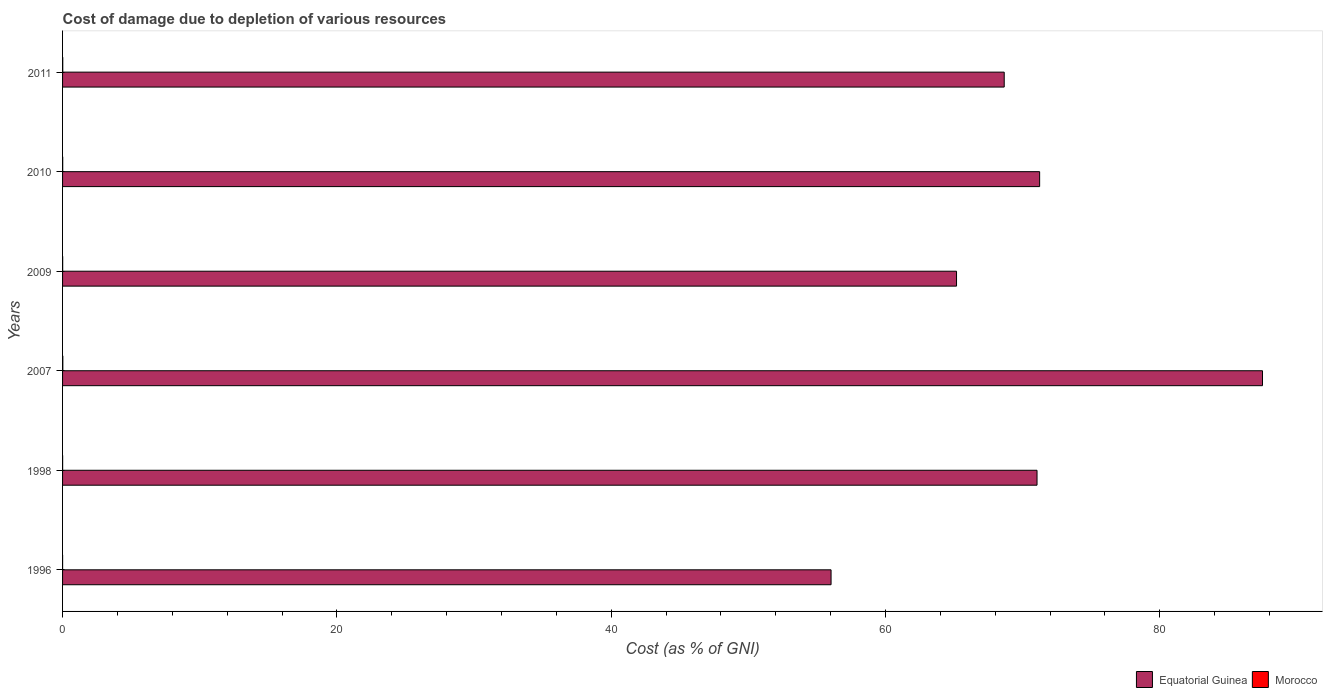Are the number of bars on each tick of the Y-axis equal?
Provide a succinct answer. Yes. How many bars are there on the 5th tick from the top?
Provide a short and direct response. 2. In how many cases, is the number of bars for a given year not equal to the number of legend labels?
Your response must be concise. 0. What is the cost of damage caused due to the depletion of various resources in Morocco in 2009?
Keep it short and to the point. 0.01. Across all years, what is the maximum cost of damage caused due to the depletion of various resources in Equatorial Guinea?
Your answer should be compact. 87.49. Across all years, what is the minimum cost of damage caused due to the depletion of various resources in Morocco?
Keep it short and to the point. 0. In which year was the cost of damage caused due to the depletion of various resources in Equatorial Guinea maximum?
Your answer should be compact. 2007. In which year was the cost of damage caused due to the depletion of various resources in Equatorial Guinea minimum?
Provide a short and direct response. 1996. What is the total cost of damage caused due to the depletion of various resources in Equatorial Guinea in the graph?
Offer a very short reply. 419.63. What is the difference between the cost of damage caused due to the depletion of various resources in Equatorial Guinea in 1996 and that in 2011?
Offer a very short reply. -12.62. What is the difference between the cost of damage caused due to the depletion of various resources in Morocco in 2010 and the cost of damage caused due to the depletion of various resources in Equatorial Guinea in 1996?
Give a very brief answer. -56.02. What is the average cost of damage caused due to the depletion of various resources in Equatorial Guinea per year?
Provide a short and direct response. 69.94. In the year 2007, what is the difference between the cost of damage caused due to the depletion of various resources in Morocco and cost of damage caused due to the depletion of various resources in Equatorial Guinea?
Offer a very short reply. -87.47. What is the ratio of the cost of damage caused due to the depletion of various resources in Morocco in 2007 to that in 2009?
Make the answer very short. 2.58. Is the cost of damage caused due to the depletion of various resources in Morocco in 2009 less than that in 2010?
Offer a terse response. Yes. What is the difference between the highest and the second highest cost of damage caused due to the depletion of various resources in Morocco?
Make the answer very short. 0.01. What is the difference between the highest and the lowest cost of damage caused due to the depletion of various resources in Morocco?
Provide a short and direct response. 0.02. What does the 2nd bar from the top in 1996 represents?
Ensure brevity in your answer.  Equatorial Guinea. What does the 2nd bar from the bottom in 2011 represents?
Provide a succinct answer. Morocco. Are all the bars in the graph horizontal?
Ensure brevity in your answer.  Yes. Are the values on the major ticks of X-axis written in scientific E-notation?
Your response must be concise. No. Does the graph contain grids?
Your answer should be compact. No. Where does the legend appear in the graph?
Give a very brief answer. Bottom right. What is the title of the graph?
Give a very brief answer. Cost of damage due to depletion of various resources. Does "Netherlands" appear as one of the legend labels in the graph?
Ensure brevity in your answer.  No. What is the label or title of the X-axis?
Keep it short and to the point. Cost (as % of GNI). What is the label or title of the Y-axis?
Provide a succinct answer. Years. What is the Cost (as % of GNI) of Equatorial Guinea in 1996?
Your answer should be compact. 56.03. What is the Cost (as % of GNI) in Morocco in 1996?
Provide a succinct answer. 0. What is the Cost (as % of GNI) in Equatorial Guinea in 1998?
Offer a very short reply. 71.05. What is the Cost (as % of GNI) in Morocco in 1998?
Make the answer very short. 0. What is the Cost (as % of GNI) of Equatorial Guinea in 2007?
Your answer should be compact. 87.49. What is the Cost (as % of GNI) of Morocco in 2007?
Your response must be concise. 0.02. What is the Cost (as % of GNI) of Equatorial Guinea in 2009?
Ensure brevity in your answer.  65.18. What is the Cost (as % of GNI) of Morocco in 2009?
Provide a short and direct response. 0.01. What is the Cost (as % of GNI) of Equatorial Guinea in 2010?
Offer a terse response. 71.24. What is the Cost (as % of GNI) in Morocco in 2010?
Make the answer very short. 0.01. What is the Cost (as % of GNI) in Equatorial Guinea in 2011?
Make the answer very short. 68.65. What is the Cost (as % of GNI) in Morocco in 2011?
Give a very brief answer. 0.01. Across all years, what is the maximum Cost (as % of GNI) of Equatorial Guinea?
Ensure brevity in your answer.  87.49. Across all years, what is the maximum Cost (as % of GNI) of Morocco?
Make the answer very short. 0.02. Across all years, what is the minimum Cost (as % of GNI) of Equatorial Guinea?
Offer a terse response. 56.03. Across all years, what is the minimum Cost (as % of GNI) in Morocco?
Your response must be concise. 0. What is the total Cost (as % of GNI) in Equatorial Guinea in the graph?
Keep it short and to the point. 419.63. What is the total Cost (as % of GNI) of Morocco in the graph?
Your response must be concise. 0.06. What is the difference between the Cost (as % of GNI) of Equatorial Guinea in 1996 and that in 1998?
Your answer should be very brief. -15.02. What is the difference between the Cost (as % of GNI) of Morocco in 1996 and that in 1998?
Offer a terse response. -0. What is the difference between the Cost (as % of GNI) of Equatorial Guinea in 1996 and that in 2007?
Your response must be concise. -31.45. What is the difference between the Cost (as % of GNI) of Morocco in 1996 and that in 2007?
Give a very brief answer. -0.02. What is the difference between the Cost (as % of GNI) of Equatorial Guinea in 1996 and that in 2009?
Keep it short and to the point. -9.15. What is the difference between the Cost (as % of GNI) in Morocco in 1996 and that in 2009?
Your answer should be compact. -0. What is the difference between the Cost (as % of GNI) of Equatorial Guinea in 1996 and that in 2010?
Provide a short and direct response. -15.21. What is the difference between the Cost (as % of GNI) of Morocco in 1996 and that in 2010?
Give a very brief answer. -0.01. What is the difference between the Cost (as % of GNI) of Equatorial Guinea in 1996 and that in 2011?
Keep it short and to the point. -12.62. What is the difference between the Cost (as % of GNI) of Morocco in 1996 and that in 2011?
Your answer should be compact. -0.01. What is the difference between the Cost (as % of GNI) in Equatorial Guinea in 1998 and that in 2007?
Your answer should be very brief. -16.44. What is the difference between the Cost (as % of GNI) of Morocco in 1998 and that in 2007?
Provide a succinct answer. -0.01. What is the difference between the Cost (as % of GNI) of Equatorial Guinea in 1998 and that in 2009?
Your answer should be compact. 5.87. What is the difference between the Cost (as % of GNI) of Morocco in 1998 and that in 2009?
Provide a short and direct response. -0. What is the difference between the Cost (as % of GNI) in Equatorial Guinea in 1998 and that in 2010?
Your response must be concise. -0.19. What is the difference between the Cost (as % of GNI) of Morocco in 1998 and that in 2010?
Your answer should be very brief. -0.01. What is the difference between the Cost (as % of GNI) in Equatorial Guinea in 1998 and that in 2011?
Your response must be concise. 2.39. What is the difference between the Cost (as % of GNI) in Morocco in 1998 and that in 2011?
Your response must be concise. -0.01. What is the difference between the Cost (as % of GNI) of Equatorial Guinea in 2007 and that in 2009?
Offer a terse response. 22.31. What is the difference between the Cost (as % of GNI) in Morocco in 2007 and that in 2009?
Your answer should be compact. 0.01. What is the difference between the Cost (as % of GNI) of Equatorial Guinea in 2007 and that in 2010?
Provide a succinct answer. 16.25. What is the difference between the Cost (as % of GNI) of Morocco in 2007 and that in 2010?
Provide a short and direct response. 0.01. What is the difference between the Cost (as % of GNI) of Equatorial Guinea in 2007 and that in 2011?
Give a very brief answer. 18.83. What is the difference between the Cost (as % of GNI) of Morocco in 2007 and that in 2011?
Offer a terse response. 0.01. What is the difference between the Cost (as % of GNI) in Equatorial Guinea in 2009 and that in 2010?
Provide a succinct answer. -6.06. What is the difference between the Cost (as % of GNI) of Morocco in 2009 and that in 2010?
Offer a very short reply. -0. What is the difference between the Cost (as % of GNI) in Equatorial Guinea in 2009 and that in 2011?
Your answer should be very brief. -3.48. What is the difference between the Cost (as % of GNI) in Morocco in 2009 and that in 2011?
Ensure brevity in your answer.  -0.01. What is the difference between the Cost (as % of GNI) in Equatorial Guinea in 2010 and that in 2011?
Offer a terse response. 2.58. What is the difference between the Cost (as % of GNI) in Morocco in 2010 and that in 2011?
Your response must be concise. -0. What is the difference between the Cost (as % of GNI) of Equatorial Guinea in 1996 and the Cost (as % of GNI) of Morocco in 1998?
Provide a short and direct response. 56.03. What is the difference between the Cost (as % of GNI) of Equatorial Guinea in 1996 and the Cost (as % of GNI) of Morocco in 2007?
Your answer should be very brief. 56.01. What is the difference between the Cost (as % of GNI) in Equatorial Guinea in 1996 and the Cost (as % of GNI) in Morocco in 2009?
Your response must be concise. 56.02. What is the difference between the Cost (as % of GNI) in Equatorial Guinea in 1996 and the Cost (as % of GNI) in Morocco in 2010?
Provide a succinct answer. 56.02. What is the difference between the Cost (as % of GNI) of Equatorial Guinea in 1996 and the Cost (as % of GNI) of Morocco in 2011?
Your response must be concise. 56.02. What is the difference between the Cost (as % of GNI) of Equatorial Guinea in 1998 and the Cost (as % of GNI) of Morocco in 2007?
Your answer should be very brief. 71.03. What is the difference between the Cost (as % of GNI) of Equatorial Guinea in 1998 and the Cost (as % of GNI) of Morocco in 2009?
Your answer should be very brief. 71.04. What is the difference between the Cost (as % of GNI) of Equatorial Guinea in 1998 and the Cost (as % of GNI) of Morocco in 2010?
Your answer should be very brief. 71.04. What is the difference between the Cost (as % of GNI) of Equatorial Guinea in 1998 and the Cost (as % of GNI) of Morocco in 2011?
Provide a short and direct response. 71.03. What is the difference between the Cost (as % of GNI) of Equatorial Guinea in 2007 and the Cost (as % of GNI) of Morocco in 2009?
Give a very brief answer. 87.48. What is the difference between the Cost (as % of GNI) of Equatorial Guinea in 2007 and the Cost (as % of GNI) of Morocco in 2010?
Give a very brief answer. 87.48. What is the difference between the Cost (as % of GNI) of Equatorial Guinea in 2007 and the Cost (as % of GNI) of Morocco in 2011?
Ensure brevity in your answer.  87.47. What is the difference between the Cost (as % of GNI) in Equatorial Guinea in 2009 and the Cost (as % of GNI) in Morocco in 2010?
Ensure brevity in your answer.  65.17. What is the difference between the Cost (as % of GNI) of Equatorial Guinea in 2009 and the Cost (as % of GNI) of Morocco in 2011?
Provide a succinct answer. 65.16. What is the difference between the Cost (as % of GNI) in Equatorial Guinea in 2010 and the Cost (as % of GNI) in Morocco in 2011?
Your response must be concise. 71.22. What is the average Cost (as % of GNI) of Equatorial Guinea per year?
Give a very brief answer. 69.94. What is the average Cost (as % of GNI) in Morocco per year?
Provide a short and direct response. 0.01. In the year 1996, what is the difference between the Cost (as % of GNI) in Equatorial Guinea and Cost (as % of GNI) in Morocco?
Ensure brevity in your answer.  56.03. In the year 1998, what is the difference between the Cost (as % of GNI) of Equatorial Guinea and Cost (as % of GNI) of Morocco?
Provide a succinct answer. 71.04. In the year 2007, what is the difference between the Cost (as % of GNI) of Equatorial Guinea and Cost (as % of GNI) of Morocco?
Ensure brevity in your answer.  87.47. In the year 2009, what is the difference between the Cost (as % of GNI) in Equatorial Guinea and Cost (as % of GNI) in Morocco?
Give a very brief answer. 65.17. In the year 2010, what is the difference between the Cost (as % of GNI) in Equatorial Guinea and Cost (as % of GNI) in Morocco?
Your answer should be compact. 71.23. In the year 2011, what is the difference between the Cost (as % of GNI) of Equatorial Guinea and Cost (as % of GNI) of Morocco?
Keep it short and to the point. 68.64. What is the ratio of the Cost (as % of GNI) in Equatorial Guinea in 1996 to that in 1998?
Your answer should be compact. 0.79. What is the ratio of the Cost (as % of GNI) in Morocco in 1996 to that in 1998?
Provide a succinct answer. 0.6. What is the ratio of the Cost (as % of GNI) in Equatorial Guinea in 1996 to that in 2007?
Your answer should be compact. 0.64. What is the ratio of the Cost (as % of GNI) of Morocco in 1996 to that in 2007?
Your answer should be very brief. 0.13. What is the ratio of the Cost (as % of GNI) in Equatorial Guinea in 1996 to that in 2009?
Provide a short and direct response. 0.86. What is the ratio of the Cost (as % of GNI) in Morocco in 1996 to that in 2009?
Offer a very short reply. 0.33. What is the ratio of the Cost (as % of GNI) in Equatorial Guinea in 1996 to that in 2010?
Give a very brief answer. 0.79. What is the ratio of the Cost (as % of GNI) in Morocco in 1996 to that in 2010?
Your answer should be compact. 0.23. What is the ratio of the Cost (as % of GNI) of Equatorial Guinea in 1996 to that in 2011?
Offer a terse response. 0.82. What is the ratio of the Cost (as % of GNI) of Morocco in 1996 to that in 2011?
Your response must be concise. 0.19. What is the ratio of the Cost (as % of GNI) of Equatorial Guinea in 1998 to that in 2007?
Make the answer very short. 0.81. What is the ratio of the Cost (as % of GNI) of Morocco in 1998 to that in 2007?
Keep it short and to the point. 0.22. What is the ratio of the Cost (as % of GNI) in Equatorial Guinea in 1998 to that in 2009?
Offer a very short reply. 1.09. What is the ratio of the Cost (as % of GNI) in Morocco in 1998 to that in 2009?
Offer a very short reply. 0.56. What is the ratio of the Cost (as % of GNI) in Morocco in 1998 to that in 2010?
Your answer should be compact. 0.39. What is the ratio of the Cost (as % of GNI) in Equatorial Guinea in 1998 to that in 2011?
Offer a terse response. 1.03. What is the ratio of the Cost (as % of GNI) in Morocco in 1998 to that in 2011?
Offer a very short reply. 0.32. What is the ratio of the Cost (as % of GNI) in Equatorial Guinea in 2007 to that in 2009?
Provide a succinct answer. 1.34. What is the ratio of the Cost (as % of GNI) in Morocco in 2007 to that in 2009?
Your answer should be very brief. 2.58. What is the ratio of the Cost (as % of GNI) of Equatorial Guinea in 2007 to that in 2010?
Offer a terse response. 1.23. What is the ratio of the Cost (as % of GNI) in Morocco in 2007 to that in 2010?
Make the answer very short. 1.81. What is the ratio of the Cost (as % of GNI) in Equatorial Guinea in 2007 to that in 2011?
Your answer should be compact. 1.27. What is the ratio of the Cost (as % of GNI) in Morocco in 2007 to that in 2011?
Give a very brief answer. 1.47. What is the ratio of the Cost (as % of GNI) in Equatorial Guinea in 2009 to that in 2010?
Provide a succinct answer. 0.91. What is the ratio of the Cost (as % of GNI) of Morocco in 2009 to that in 2010?
Keep it short and to the point. 0.7. What is the ratio of the Cost (as % of GNI) of Equatorial Guinea in 2009 to that in 2011?
Offer a very short reply. 0.95. What is the ratio of the Cost (as % of GNI) in Morocco in 2009 to that in 2011?
Keep it short and to the point. 0.57. What is the ratio of the Cost (as % of GNI) of Equatorial Guinea in 2010 to that in 2011?
Provide a succinct answer. 1.04. What is the ratio of the Cost (as % of GNI) in Morocco in 2010 to that in 2011?
Your answer should be very brief. 0.81. What is the difference between the highest and the second highest Cost (as % of GNI) of Equatorial Guinea?
Your answer should be compact. 16.25. What is the difference between the highest and the second highest Cost (as % of GNI) of Morocco?
Provide a succinct answer. 0.01. What is the difference between the highest and the lowest Cost (as % of GNI) of Equatorial Guinea?
Offer a terse response. 31.45. What is the difference between the highest and the lowest Cost (as % of GNI) of Morocco?
Provide a succinct answer. 0.02. 